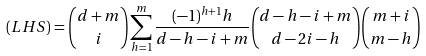Convert formula to latex. <formula><loc_0><loc_0><loc_500><loc_500>( L H S ) & = \binom { d + m } { i } \sum _ { h = 1 } ^ { m } \frac { ( - 1 ) ^ { h + 1 } h } { d - h - i + m } \binom { d - h - i + m } { d - 2 i - h } \binom { m + i } { m - h }</formula> 